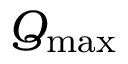Convert formula to latex. <formula><loc_0><loc_0><loc_500><loc_500>Q _ { \max }</formula> 